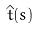<formula> <loc_0><loc_0><loc_500><loc_500>\hat { t } ( s )</formula> 